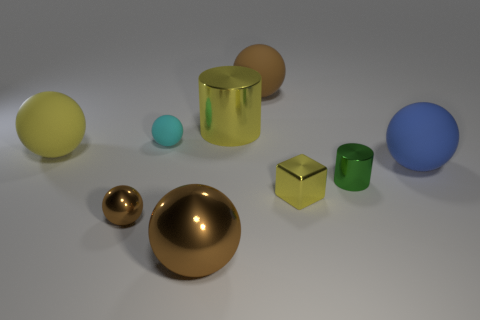Subtract all yellow spheres. How many spheres are left? 5 Subtract all balls. How many objects are left? 3 Subtract all red spheres. How many cyan blocks are left? 0 Subtract all tiny blue rubber things. Subtract all yellow shiny cylinders. How many objects are left? 8 Add 4 small cubes. How many small cubes are left? 5 Add 2 green matte blocks. How many green matte blocks exist? 2 Subtract all yellow spheres. How many spheres are left? 5 Subtract 0 purple balls. How many objects are left? 9 Subtract 1 cubes. How many cubes are left? 0 Subtract all purple spheres. Subtract all red cubes. How many spheres are left? 6 